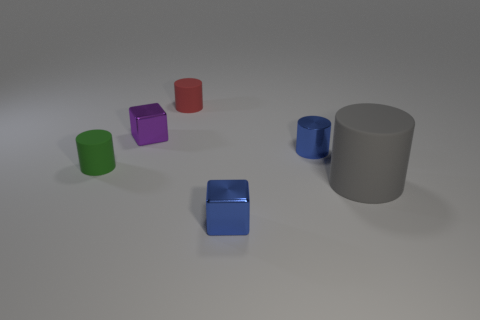Is there anything else that is the same size as the gray thing?
Ensure brevity in your answer.  No. Is there any other thing that is the same color as the large rubber cylinder?
Offer a very short reply. No. Is the number of tiny blue cylinders that are in front of the red object less than the number of big red matte cylinders?
Ensure brevity in your answer.  No. Is the number of gray rubber cylinders greater than the number of red rubber blocks?
Provide a short and direct response. Yes. Is there a green object right of the matte object that is behind the small matte thing in front of the red matte thing?
Your answer should be compact. No. How many other things are there of the same size as the gray rubber cylinder?
Make the answer very short. 0. Are there any gray rubber cylinders on the left side of the large matte object?
Provide a succinct answer. No. Does the shiny cylinder have the same color as the metallic cube in front of the metal cylinder?
Make the answer very short. Yes. What is the color of the cube right of the rubber cylinder that is behind the cylinder that is left of the purple block?
Offer a very short reply. Blue. Is there a blue metal object of the same shape as the large gray rubber thing?
Your answer should be compact. Yes. 